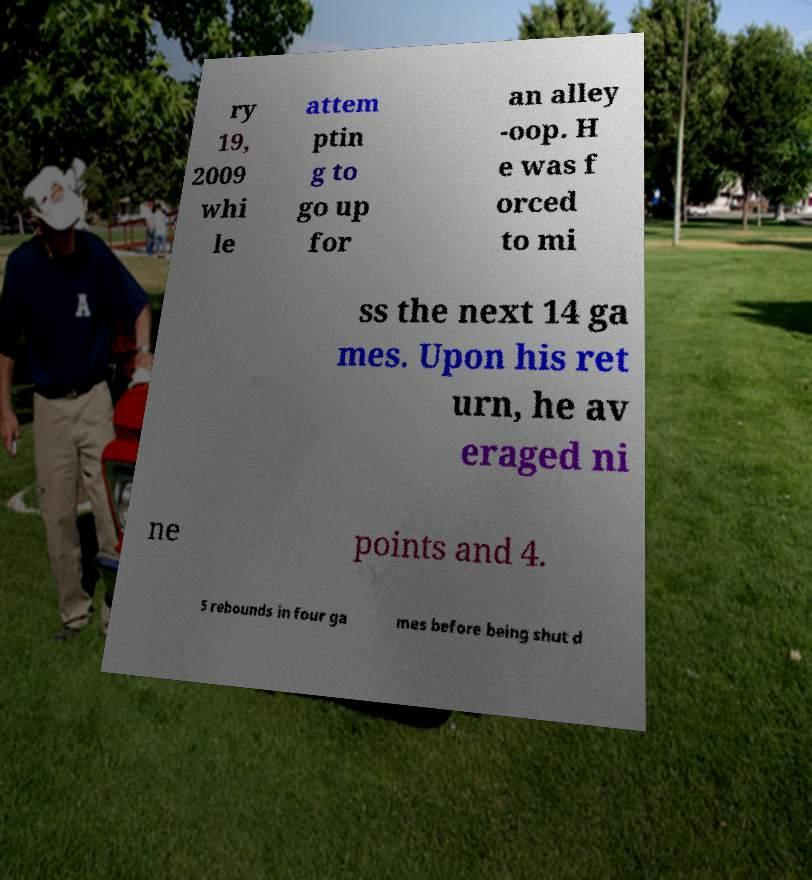Can you accurately transcribe the text from the provided image for me? ry 19, 2009 whi le attem ptin g to go up for an alley -oop. H e was f orced to mi ss the next 14 ga mes. Upon his ret urn, he av eraged ni ne points and 4. 5 rebounds in four ga mes before being shut d 